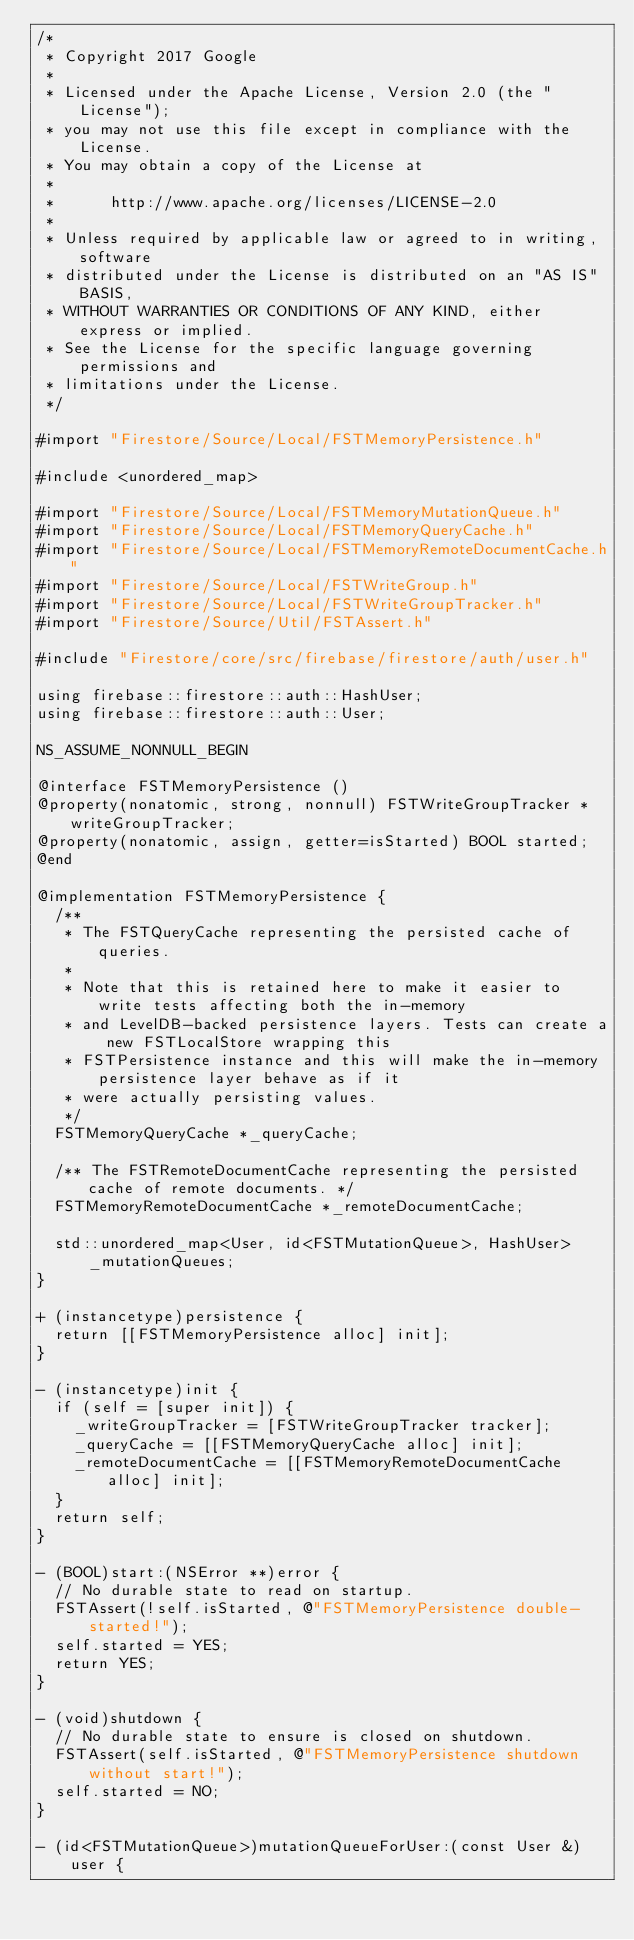<code> <loc_0><loc_0><loc_500><loc_500><_ObjectiveC_>/*
 * Copyright 2017 Google
 *
 * Licensed under the Apache License, Version 2.0 (the "License");
 * you may not use this file except in compliance with the License.
 * You may obtain a copy of the License at
 *
 *      http://www.apache.org/licenses/LICENSE-2.0
 *
 * Unless required by applicable law or agreed to in writing, software
 * distributed under the License is distributed on an "AS IS" BASIS,
 * WITHOUT WARRANTIES OR CONDITIONS OF ANY KIND, either express or implied.
 * See the License for the specific language governing permissions and
 * limitations under the License.
 */

#import "Firestore/Source/Local/FSTMemoryPersistence.h"

#include <unordered_map>

#import "Firestore/Source/Local/FSTMemoryMutationQueue.h"
#import "Firestore/Source/Local/FSTMemoryQueryCache.h"
#import "Firestore/Source/Local/FSTMemoryRemoteDocumentCache.h"
#import "Firestore/Source/Local/FSTWriteGroup.h"
#import "Firestore/Source/Local/FSTWriteGroupTracker.h"
#import "Firestore/Source/Util/FSTAssert.h"

#include "Firestore/core/src/firebase/firestore/auth/user.h"

using firebase::firestore::auth::HashUser;
using firebase::firestore::auth::User;

NS_ASSUME_NONNULL_BEGIN

@interface FSTMemoryPersistence ()
@property(nonatomic, strong, nonnull) FSTWriteGroupTracker *writeGroupTracker;
@property(nonatomic, assign, getter=isStarted) BOOL started;
@end

@implementation FSTMemoryPersistence {
  /**
   * The FSTQueryCache representing the persisted cache of queries.
   *
   * Note that this is retained here to make it easier to write tests affecting both the in-memory
   * and LevelDB-backed persistence layers. Tests can create a new FSTLocalStore wrapping this
   * FSTPersistence instance and this will make the in-memory persistence layer behave as if it
   * were actually persisting values.
   */
  FSTMemoryQueryCache *_queryCache;

  /** The FSTRemoteDocumentCache representing the persisted cache of remote documents. */
  FSTMemoryRemoteDocumentCache *_remoteDocumentCache;

  std::unordered_map<User, id<FSTMutationQueue>, HashUser> _mutationQueues;
}

+ (instancetype)persistence {
  return [[FSTMemoryPersistence alloc] init];
}

- (instancetype)init {
  if (self = [super init]) {
    _writeGroupTracker = [FSTWriteGroupTracker tracker];
    _queryCache = [[FSTMemoryQueryCache alloc] init];
    _remoteDocumentCache = [[FSTMemoryRemoteDocumentCache alloc] init];
  }
  return self;
}

- (BOOL)start:(NSError **)error {
  // No durable state to read on startup.
  FSTAssert(!self.isStarted, @"FSTMemoryPersistence double-started!");
  self.started = YES;
  return YES;
}

- (void)shutdown {
  // No durable state to ensure is closed on shutdown.
  FSTAssert(self.isStarted, @"FSTMemoryPersistence shutdown without start!");
  self.started = NO;
}

- (id<FSTMutationQueue>)mutationQueueForUser:(const User &)user {</code> 